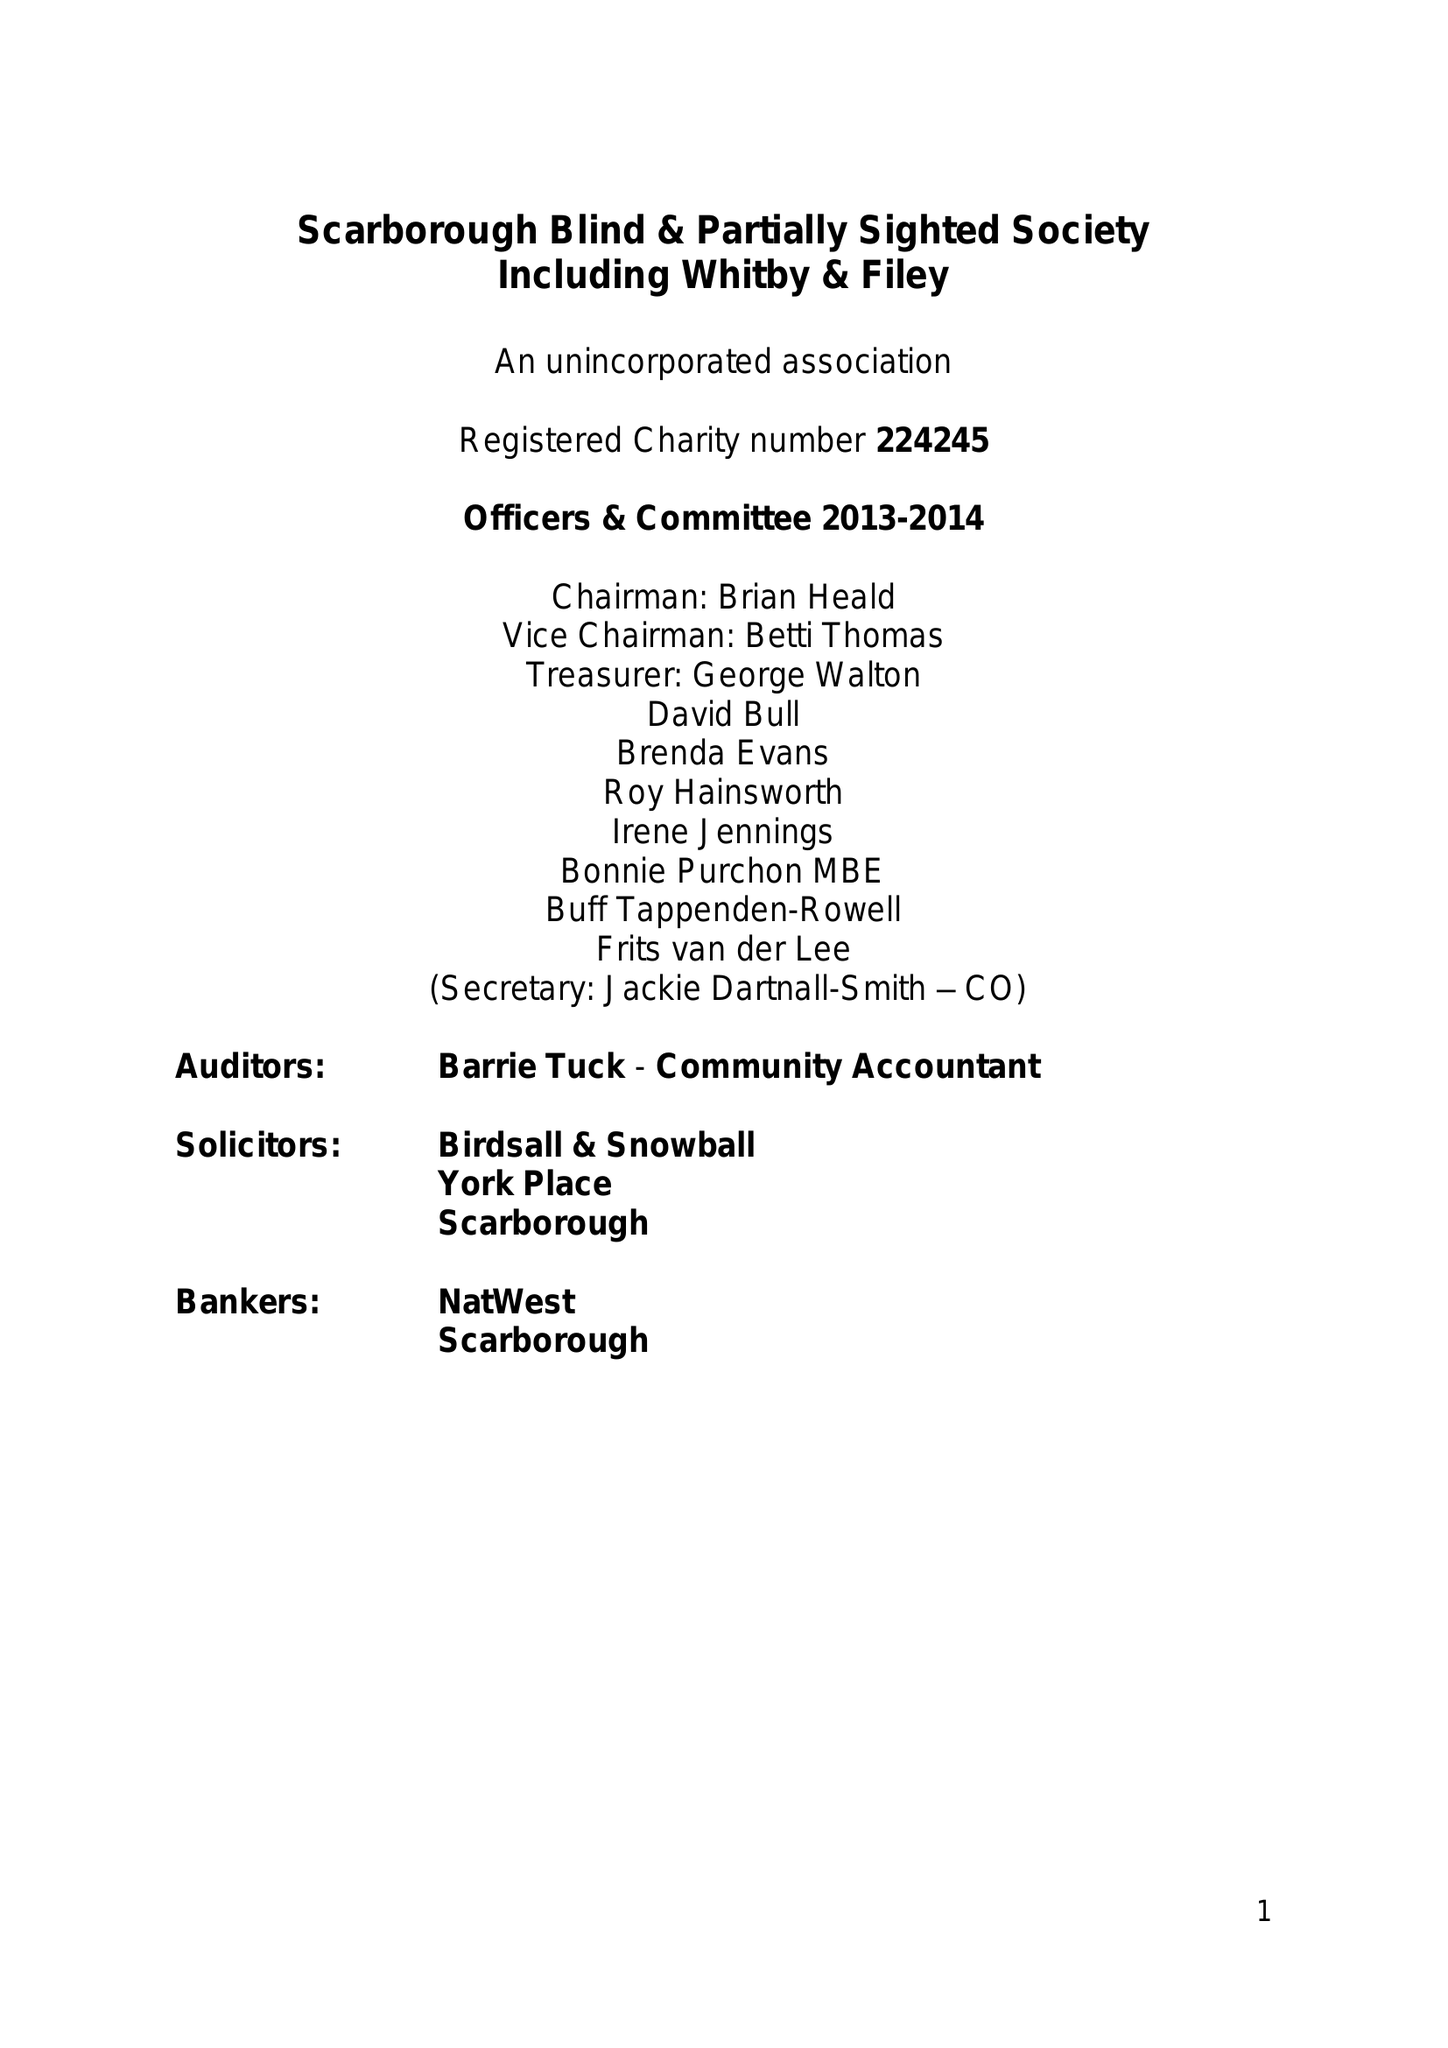What is the value for the income_annually_in_british_pounds?
Answer the question using a single word or phrase. 66028.00 